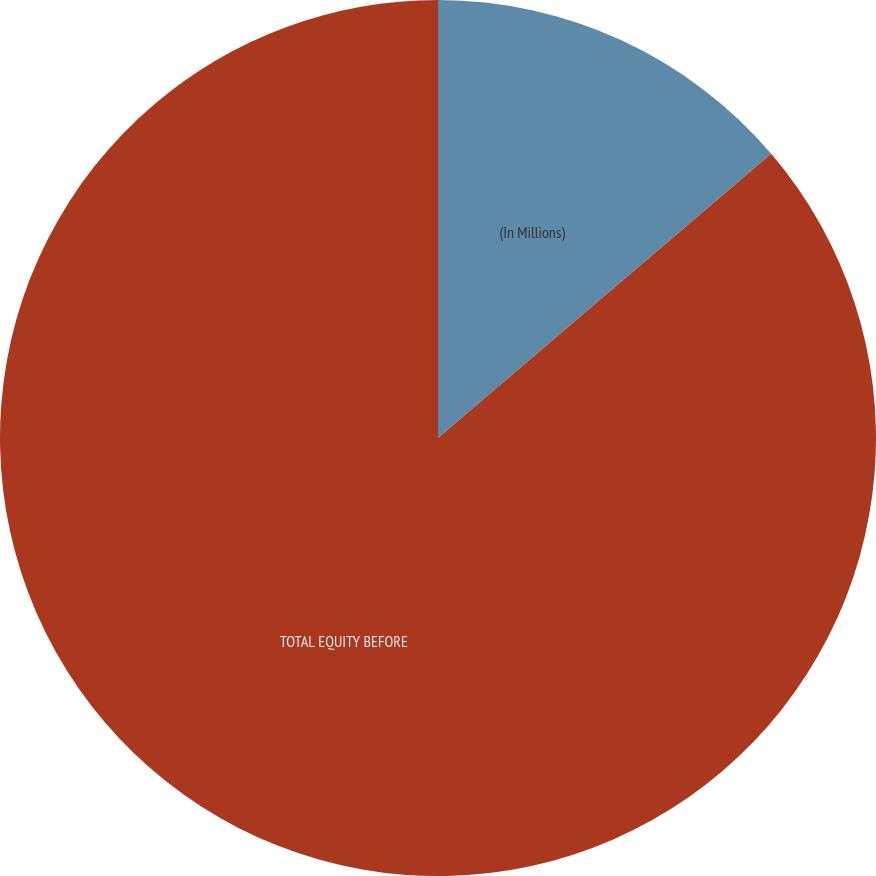<chart> <loc_0><loc_0><loc_500><loc_500><pie_chart><fcel>(In Millions)<fcel>TOTAL EQUITY BEFORE<nl><fcel>13.76%<fcel>86.24%<nl></chart> 